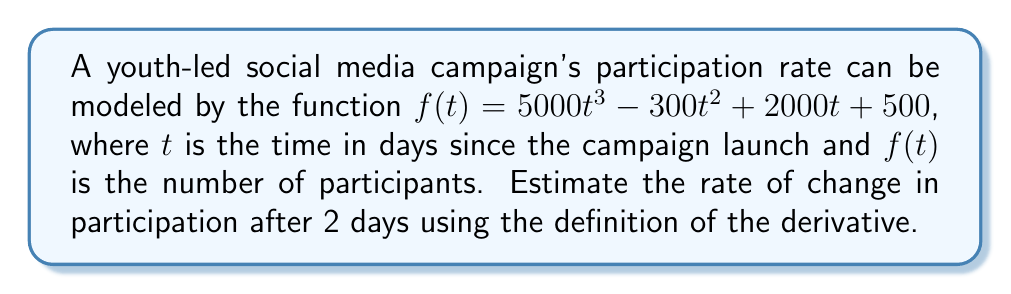Solve this math problem. To estimate the derivative of $f(t)$ at $t=2$, we'll use the definition of the derivative:

$$f'(2) = \lim_{h \to 0} \frac{f(2+h) - f(2)}{h}$$

Step 1: Calculate $f(2)$
$$f(2) = 5000(2^3) - 300(2^2) + 2000(2) + 500 = 40000 - 1200 + 4000 + 500 = 43300$$

Step 2: Calculate $f(2+h)$
$$\begin{align*}
f(2+h) &= 5000(2+h)^3 - 300(2+h)^2 + 2000(2+h) + 500 \\
&= 5000(8+12h+6h^2+h^3) - 300(4+4h+h^2) + 2000(2+h) + 500 \\
&= 40000 + 60000h + 30000h^2 + 5000h^3 - 1200 - 1200h - 300h^2 + 4000 + 2000h + 500 \\
&= 43300 + 60800h + 29700h^2 + 5000h^3
\end{align*}$$

Step 3: Calculate $\frac{f(2+h) - f(2)}{h}$
$$\begin{align*}
\frac{f(2+h) - f(2)}{h} &= \frac{(43300 + 60800h + 29700h^2 + 5000h^3) - 43300}{h} \\
&= \frac{60800h + 29700h^2 + 5000h^3}{h} \\
&= 60800 + 29700h + 5000h^2
\end{align*}$$

Step 4: Take the limit as $h$ approaches 0
$$\lim_{h \to 0} (60800 + 29700h + 5000h^2) = 60800$$

Therefore, the estimated rate of change in participation after 2 days is 60,800 participants per day.
Answer: 60,800 participants/day 